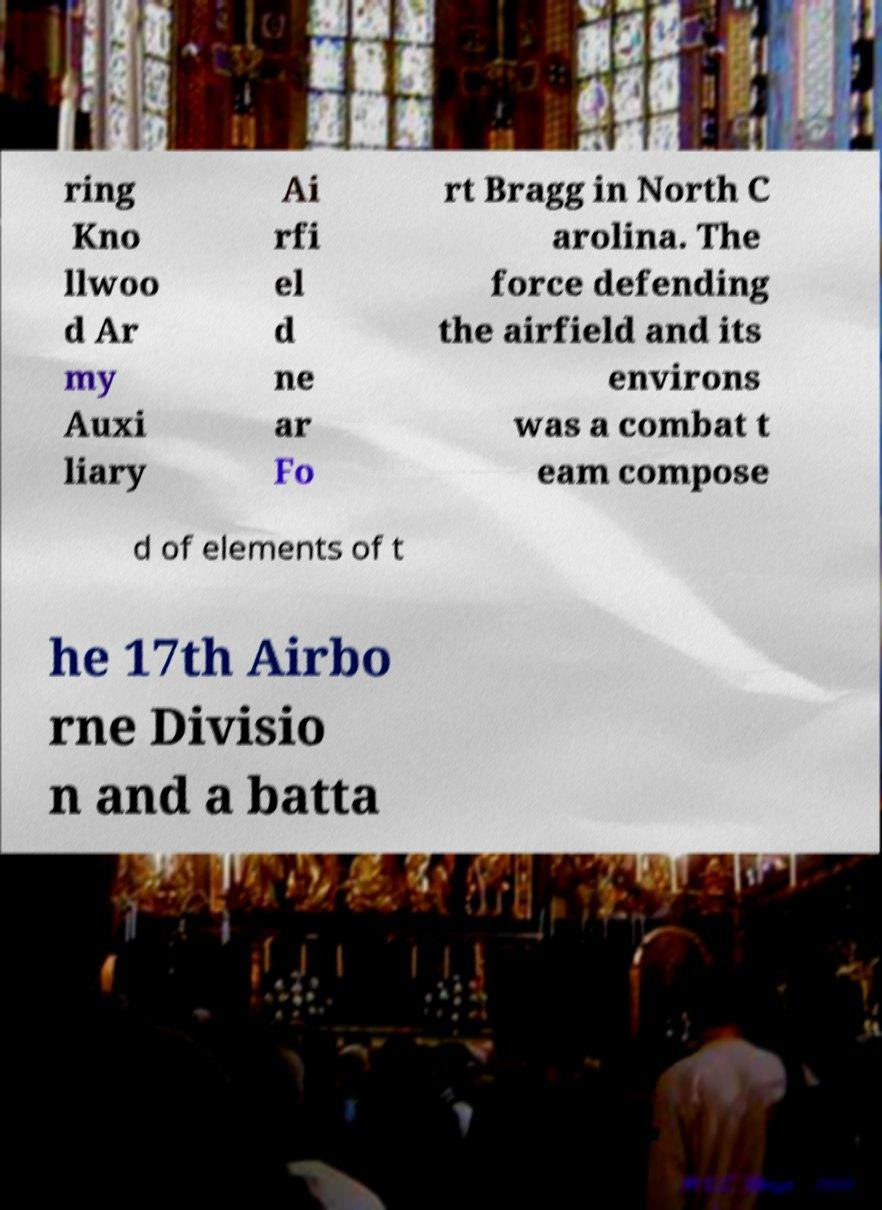Could you assist in decoding the text presented in this image and type it out clearly? ring Kno llwoo d Ar my Auxi liary Ai rfi el d ne ar Fo rt Bragg in North C arolina. The force defending the airfield and its environs was a combat t eam compose d of elements of t he 17th Airbo rne Divisio n and a batta 